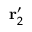Convert formula to latex. <formula><loc_0><loc_0><loc_500><loc_500>r _ { 2 } ^ { \prime }</formula> 